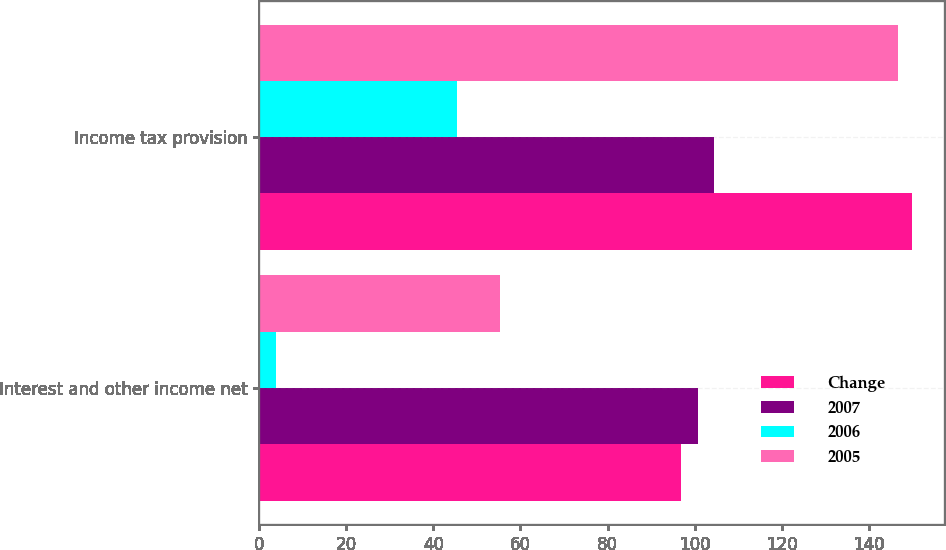Convert chart. <chart><loc_0><loc_0><loc_500><loc_500><stacked_bar_chart><ecel><fcel>Interest and other income net<fcel>Income tax provision<nl><fcel>Change<fcel>96.8<fcel>149.8<nl><fcel>2007<fcel>100.7<fcel>104.4<nl><fcel>2006<fcel>3.9<fcel>45.4<nl><fcel>2005<fcel>55.2<fcel>146.8<nl></chart> 